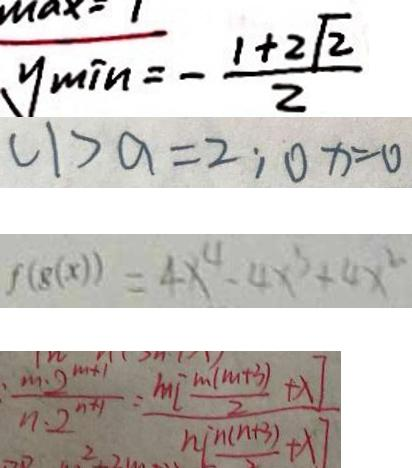<formula> <loc_0><loc_0><loc_500><loc_500>y _ { \min } = - \frac { 1 + 2 \sqrt { 2 } } { 2 } 
 ( 1 ) a = 2 ; 0 x = 0 
 f ( g ( x ) ) = 4 x ^ { 4 } - 4 x ^ { 3 } + 4 x ^ { 2 } 
 : \frac { m \cdot 2 ^ { m + 1 } } { n \cdot 2 ^ { n + 1 } } = \frac { m [ \frac { m ( m + 3 ) } { 2 } + \lambda ] } { n [ \frac { n ( n + 3 ) } { 2 } + \lambda ] }</formula> 